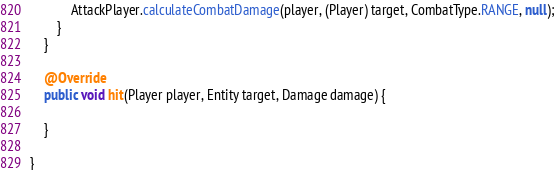<code> <loc_0><loc_0><loc_500><loc_500><_Java_>			AttackPlayer.calculateCombatDamage(player, (Player) target, CombatType.RANGE, null);
		}
	}

	@Override
	public void hit(Player player, Entity target, Damage damage) {

	}

}
</code> 